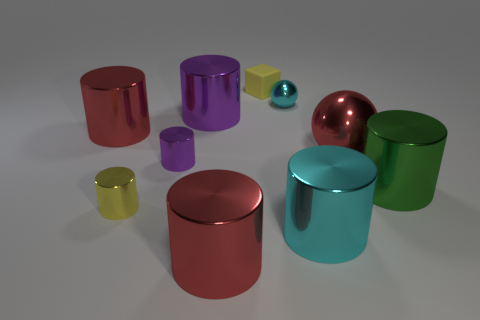Subtract all green cylinders. How many cylinders are left? 6 Subtract all tiny yellow cylinders. How many cylinders are left? 6 Subtract 2 cylinders. How many cylinders are left? 5 Subtract all cyan cylinders. Subtract all blue spheres. How many cylinders are left? 6 Subtract all cylinders. How many objects are left? 3 Add 1 tiny purple metal spheres. How many tiny purple metal spheres exist? 1 Subtract 1 yellow cylinders. How many objects are left? 9 Subtract all cyan rubber blocks. Subtract all tiny purple cylinders. How many objects are left? 9 Add 8 small cubes. How many small cubes are left? 9 